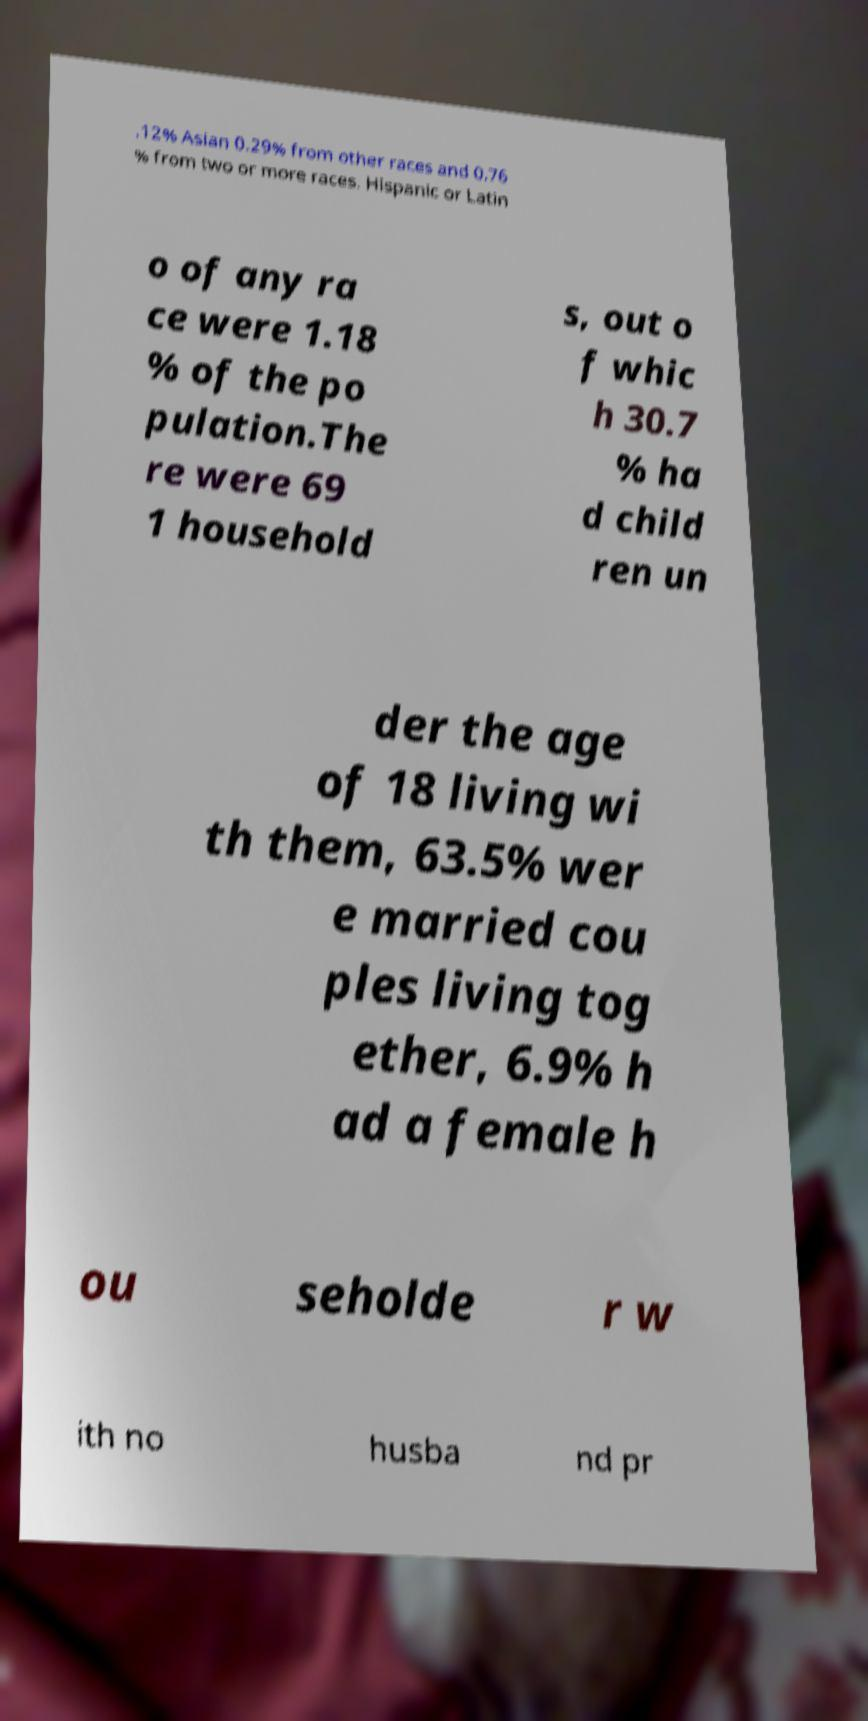Please identify and transcribe the text found in this image. .12% Asian 0.29% from other races and 0.76 % from two or more races. Hispanic or Latin o of any ra ce were 1.18 % of the po pulation.The re were 69 1 household s, out o f whic h 30.7 % ha d child ren un der the age of 18 living wi th them, 63.5% wer e married cou ples living tog ether, 6.9% h ad a female h ou seholde r w ith no husba nd pr 